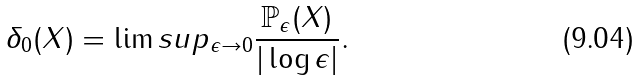Convert formula to latex. <formula><loc_0><loc_0><loc_500><loc_500>\delta _ { 0 } ( X ) = \lim s u p _ { \epsilon \rightarrow 0 } \frac { \mathbb { P } _ { \epsilon } ( X ) } { | \log \epsilon | } .</formula> 